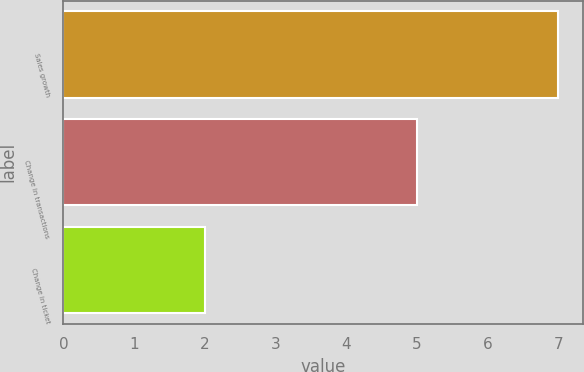<chart> <loc_0><loc_0><loc_500><loc_500><bar_chart><fcel>Sales growth<fcel>Change in transactions<fcel>Change in ticket<nl><fcel>7<fcel>5<fcel>2<nl></chart> 